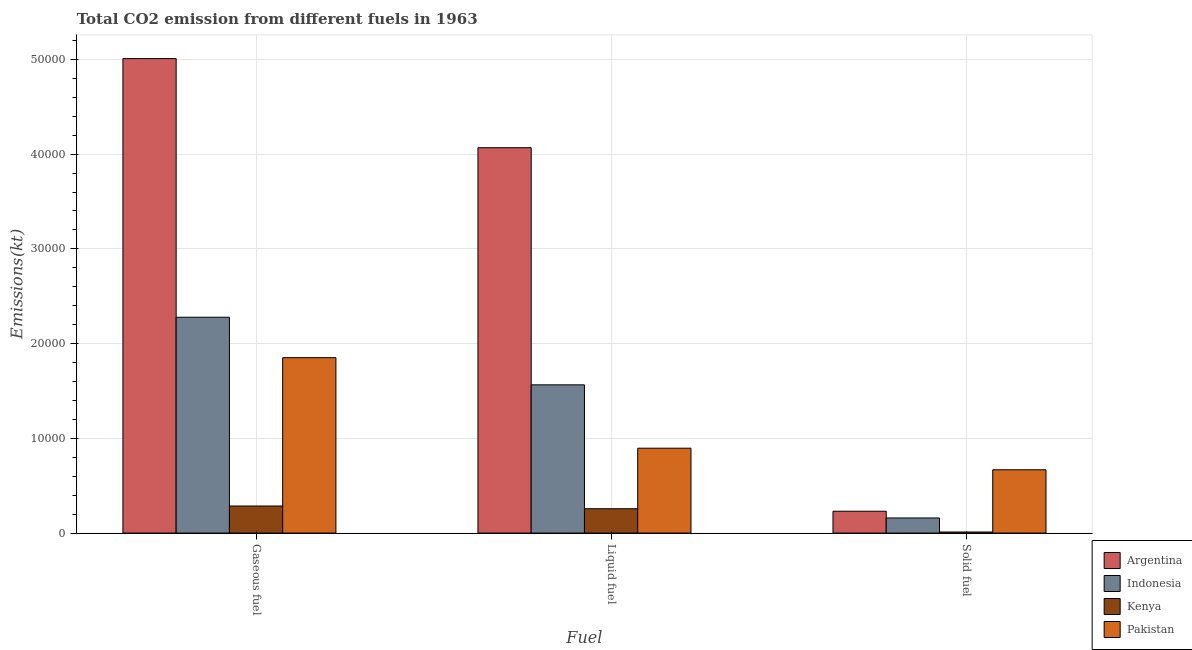How many groups of bars are there?
Your answer should be very brief. 3. Are the number of bars on each tick of the X-axis equal?
Offer a terse response. Yes. What is the label of the 1st group of bars from the left?
Provide a succinct answer. Gaseous fuel. What is the amount of co2 emissions from liquid fuel in Pakistan?
Your answer should be very brief. 8958.48. Across all countries, what is the maximum amount of co2 emissions from liquid fuel?
Provide a short and direct response. 4.07e+04. Across all countries, what is the minimum amount of co2 emissions from gaseous fuel?
Offer a terse response. 2856.59. In which country was the amount of co2 emissions from gaseous fuel minimum?
Your response must be concise. Kenya. What is the total amount of co2 emissions from liquid fuel in the graph?
Offer a very short reply. 6.79e+04. What is the difference between the amount of co2 emissions from liquid fuel in Indonesia and that in Kenya?
Give a very brief answer. 1.31e+04. What is the difference between the amount of co2 emissions from gaseous fuel in Pakistan and the amount of co2 emissions from liquid fuel in Kenya?
Your answer should be compact. 1.59e+04. What is the average amount of co2 emissions from solid fuel per country?
Your answer should be compact. 2674.16. What is the difference between the amount of co2 emissions from gaseous fuel and amount of co2 emissions from solid fuel in Argentina?
Your response must be concise. 4.78e+04. In how many countries, is the amount of co2 emissions from solid fuel greater than 50000 kt?
Give a very brief answer. 0. What is the ratio of the amount of co2 emissions from solid fuel in Pakistan to that in Kenya?
Offer a very short reply. 58.77. Is the amount of co2 emissions from solid fuel in Argentina less than that in Indonesia?
Your response must be concise. No. Is the difference between the amount of co2 emissions from solid fuel in Argentina and Kenya greater than the difference between the amount of co2 emissions from liquid fuel in Argentina and Kenya?
Ensure brevity in your answer.  No. What is the difference between the highest and the second highest amount of co2 emissions from liquid fuel?
Offer a very short reply. 2.50e+04. What is the difference between the highest and the lowest amount of co2 emissions from gaseous fuel?
Your response must be concise. 4.72e+04. In how many countries, is the amount of co2 emissions from liquid fuel greater than the average amount of co2 emissions from liquid fuel taken over all countries?
Keep it short and to the point. 1. Is the sum of the amount of co2 emissions from liquid fuel in Pakistan and Kenya greater than the maximum amount of co2 emissions from solid fuel across all countries?
Offer a very short reply. Yes. What does the 3rd bar from the right in Liquid fuel represents?
Your answer should be very brief. Indonesia. Is it the case that in every country, the sum of the amount of co2 emissions from gaseous fuel and amount of co2 emissions from liquid fuel is greater than the amount of co2 emissions from solid fuel?
Ensure brevity in your answer.  Yes. Are the values on the major ticks of Y-axis written in scientific E-notation?
Ensure brevity in your answer.  No. Where does the legend appear in the graph?
Keep it short and to the point. Bottom right. How are the legend labels stacked?
Give a very brief answer. Vertical. What is the title of the graph?
Offer a very short reply. Total CO2 emission from different fuels in 1963. Does "Suriname" appear as one of the legend labels in the graph?
Ensure brevity in your answer.  No. What is the label or title of the X-axis?
Your response must be concise. Fuel. What is the label or title of the Y-axis?
Offer a terse response. Emissions(kt). What is the Emissions(kt) of Argentina in Gaseous fuel?
Your answer should be very brief. 5.01e+04. What is the Emissions(kt) in Indonesia in Gaseous fuel?
Give a very brief answer. 2.28e+04. What is the Emissions(kt) of Kenya in Gaseous fuel?
Provide a succinct answer. 2856.59. What is the Emissions(kt) in Pakistan in Gaseous fuel?
Offer a very short reply. 1.85e+04. What is the Emissions(kt) of Argentina in Liquid fuel?
Provide a succinct answer. 4.07e+04. What is the Emissions(kt) of Indonesia in Liquid fuel?
Your answer should be compact. 1.56e+04. What is the Emissions(kt) in Kenya in Liquid fuel?
Make the answer very short. 2570.57. What is the Emissions(kt) in Pakistan in Liquid fuel?
Your answer should be compact. 8958.48. What is the Emissions(kt) in Argentina in Solid fuel?
Offer a terse response. 2306.54. What is the Emissions(kt) in Indonesia in Solid fuel?
Your answer should be compact. 1595.14. What is the Emissions(kt) in Kenya in Solid fuel?
Your response must be concise. 113.68. What is the Emissions(kt) of Pakistan in Solid fuel?
Offer a very short reply. 6681.27. Across all Fuel, what is the maximum Emissions(kt) in Argentina?
Offer a very short reply. 5.01e+04. Across all Fuel, what is the maximum Emissions(kt) of Indonesia?
Offer a very short reply. 2.28e+04. Across all Fuel, what is the maximum Emissions(kt) of Kenya?
Give a very brief answer. 2856.59. Across all Fuel, what is the maximum Emissions(kt) of Pakistan?
Provide a short and direct response. 1.85e+04. Across all Fuel, what is the minimum Emissions(kt) in Argentina?
Your response must be concise. 2306.54. Across all Fuel, what is the minimum Emissions(kt) of Indonesia?
Offer a terse response. 1595.14. Across all Fuel, what is the minimum Emissions(kt) in Kenya?
Offer a very short reply. 113.68. Across all Fuel, what is the minimum Emissions(kt) of Pakistan?
Your response must be concise. 6681.27. What is the total Emissions(kt) of Argentina in the graph?
Keep it short and to the point. 9.31e+04. What is the total Emissions(kt) of Indonesia in the graph?
Keep it short and to the point. 4.00e+04. What is the total Emissions(kt) of Kenya in the graph?
Offer a terse response. 5540.84. What is the total Emissions(kt) in Pakistan in the graph?
Your response must be concise. 3.42e+04. What is the difference between the Emissions(kt) of Argentina in Gaseous fuel and that in Liquid fuel?
Give a very brief answer. 9405.85. What is the difference between the Emissions(kt) in Indonesia in Gaseous fuel and that in Liquid fuel?
Your answer should be very brief. 7135.98. What is the difference between the Emissions(kt) in Kenya in Gaseous fuel and that in Liquid fuel?
Make the answer very short. 286.03. What is the difference between the Emissions(kt) in Pakistan in Gaseous fuel and that in Liquid fuel?
Offer a terse response. 9556.2. What is the difference between the Emissions(kt) of Argentina in Gaseous fuel and that in Solid fuel?
Provide a succinct answer. 4.78e+04. What is the difference between the Emissions(kt) in Indonesia in Gaseous fuel and that in Solid fuel?
Provide a succinct answer. 2.12e+04. What is the difference between the Emissions(kt) of Kenya in Gaseous fuel and that in Solid fuel?
Offer a terse response. 2742.92. What is the difference between the Emissions(kt) in Pakistan in Gaseous fuel and that in Solid fuel?
Keep it short and to the point. 1.18e+04. What is the difference between the Emissions(kt) in Argentina in Liquid fuel and that in Solid fuel?
Keep it short and to the point. 3.84e+04. What is the difference between the Emissions(kt) in Indonesia in Liquid fuel and that in Solid fuel?
Give a very brief answer. 1.41e+04. What is the difference between the Emissions(kt) in Kenya in Liquid fuel and that in Solid fuel?
Your answer should be very brief. 2456.89. What is the difference between the Emissions(kt) of Pakistan in Liquid fuel and that in Solid fuel?
Ensure brevity in your answer.  2277.21. What is the difference between the Emissions(kt) of Argentina in Gaseous fuel and the Emissions(kt) of Indonesia in Liquid fuel?
Your answer should be compact. 3.44e+04. What is the difference between the Emissions(kt) in Argentina in Gaseous fuel and the Emissions(kt) in Kenya in Liquid fuel?
Keep it short and to the point. 4.75e+04. What is the difference between the Emissions(kt) in Argentina in Gaseous fuel and the Emissions(kt) in Pakistan in Liquid fuel?
Provide a succinct answer. 4.11e+04. What is the difference between the Emissions(kt) in Indonesia in Gaseous fuel and the Emissions(kt) in Kenya in Liquid fuel?
Ensure brevity in your answer.  2.02e+04. What is the difference between the Emissions(kt) in Indonesia in Gaseous fuel and the Emissions(kt) in Pakistan in Liquid fuel?
Make the answer very short. 1.38e+04. What is the difference between the Emissions(kt) of Kenya in Gaseous fuel and the Emissions(kt) of Pakistan in Liquid fuel?
Provide a succinct answer. -6101.89. What is the difference between the Emissions(kt) in Argentina in Gaseous fuel and the Emissions(kt) in Indonesia in Solid fuel?
Provide a succinct answer. 4.85e+04. What is the difference between the Emissions(kt) of Argentina in Gaseous fuel and the Emissions(kt) of Kenya in Solid fuel?
Offer a very short reply. 5.00e+04. What is the difference between the Emissions(kt) of Argentina in Gaseous fuel and the Emissions(kt) of Pakistan in Solid fuel?
Provide a succinct answer. 4.34e+04. What is the difference between the Emissions(kt) of Indonesia in Gaseous fuel and the Emissions(kt) of Kenya in Solid fuel?
Provide a short and direct response. 2.27e+04. What is the difference between the Emissions(kt) in Indonesia in Gaseous fuel and the Emissions(kt) in Pakistan in Solid fuel?
Provide a succinct answer. 1.61e+04. What is the difference between the Emissions(kt) in Kenya in Gaseous fuel and the Emissions(kt) in Pakistan in Solid fuel?
Your response must be concise. -3824.68. What is the difference between the Emissions(kt) of Argentina in Liquid fuel and the Emissions(kt) of Indonesia in Solid fuel?
Your answer should be very brief. 3.91e+04. What is the difference between the Emissions(kt) of Argentina in Liquid fuel and the Emissions(kt) of Kenya in Solid fuel?
Offer a very short reply. 4.06e+04. What is the difference between the Emissions(kt) in Argentina in Liquid fuel and the Emissions(kt) in Pakistan in Solid fuel?
Give a very brief answer. 3.40e+04. What is the difference between the Emissions(kt) in Indonesia in Liquid fuel and the Emissions(kt) in Kenya in Solid fuel?
Your response must be concise. 1.55e+04. What is the difference between the Emissions(kt) in Indonesia in Liquid fuel and the Emissions(kt) in Pakistan in Solid fuel?
Your response must be concise. 8965.82. What is the difference between the Emissions(kt) in Kenya in Liquid fuel and the Emissions(kt) in Pakistan in Solid fuel?
Offer a very short reply. -4110.71. What is the average Emissions(kt) in Argentina per Fuel?
Your answer should be compact. 3.10e+04. What is the average Emissions(kt) in Indonesia per Fuel?
Your answer should be compact. 1.33e+04. What is the average Emissions(kt) of Kenya per Fuel?
Offer a terse response. 1846.95. What is the average Emissions(kt) of Pakistan per Fuel?
Ensure brevity in your answer.  1.14e+04. What is the difference between the Emissions(kt) in Argentina and Emissions(kt) in Indonesia in Gaseous fuel?
Offer a very short reply. 2.73e+04. What is the difference between the Emissions(kt) of Argentina and Emissions(kt) of Kenya in Gaseous fuel?
Your response must be concise. 4.72e+04. What is the difference between the Emissions(kt) of Argentina and Emissions(kt) of Pakistan in Gaseous fuel?
Offer a terse response. 3.16e+04. What is the difference between the Emissions(kt) in Indonesia and Emissions(kt) in Kenya in Gaseous fuel?
Offer a very short reply. 1.99e+04. What is the difference between the Emissions(kt) of Indonesia and Emissions(kt) of Pakistan in Gaseous fuel?
Ensure brevity in your answer.  4268.39. What is the difference between the Emissions(kt) in Kenya and Emissions(kt) in Pakistan in Gaseous fuel?
Provide a short and direct response. -1.57e+04. What is the difference between the Emissions(kt) of Argentina and Emissions(kt) of Indonesia in Liquid fuel?
Offer a terse response. 2.50e+04. What is the difference between the Emissions(kt) in Argentina and Emissions(kt) in Kenya in Liquid fuel?
Your response must be concise. 3.81e+04. What is the difference between the Emissions(kt) in Argentina and Emissions(kt) in Pakistan in Liquid fuel?
Your response must be concise. 3.17e+04. What is the difference between the Emissions(kt) in Indonesia and Emissions(kt) in Kenya in Liquid fuel?
Your answer should be compact. 1.31e+04. What is the difference between the Emissions(kt) of Indonesia and Emissions(kt) of Pakistan in Liquid fuel?
Ensure brevity in your answer.  6688.61. What is the difference between the Emissions(kt) of Kenya and Emissions(kt) of Pakistan in Liquid fuel?
Your answer should be compact. -6387.91. What is the difference between the Emissions(kt) of Argentina and Emissions(kt) of Indonesia in Solid fuel?
Provide a succinct answer. 711.4. What is the difference between the Emissions(kt) of Argentina and Emissions(kt) of Kenya in Solid fuel?
Keep it short and to the point. 2192.87. What is the difference between the Emissions(kt) in Argentina and Emissions(kt) in Pakistan in Solid fuel?
Your response must be concise. -4374.73. What is the difference between the Emissions(kt) of Indonesia and Emissions(kt) of Kenya in Solid fuel?
Give a very brief answer. 1481.47. What is the difference between the Emissions(kt) of Indonesia and Emissions(kt) of Pakistan in Solid fuel?
Your answer should be very brief. -5086.13. What is the difference between the Emissions(kt) of Kenya and Emissions(kt) of Pakistan in Solid fuel?
Provide a succinct answer. -6567.6. What is the ratio of the Emissions(kt) in Argentina in Gaseous fuel to that in Liquid fuel?
Offer a terse response. 1.23. What is the ratio of the Emissions(kt) of Indonesia in Gaseous fuel to that in Liquid fuel?
Your answer should be very brief. 1.46. What is the ratio of the Emissions(kt) in Kenya in Gaseous fuel to that in Liquid fuel?
Keep it short and to the point. 1.11. What is the ratio of the Emissions(kt) of Pakistan in Gaseous fuel to that in Liquid fuel?
Give a very brief answer. 2.07. What is the ratio of the Emissions(kt) in Argentina in Gaseous fuel to that in Solid fuel?
Provide a succinct answer. 21.71. What is the ratio of the Emissions(kt) in Indonesia in Gaseous fuel to that in Solid fuel?
Offer a terse response. 14.28. What is the ratio of the Emissions(kt) in Kenya in Gaseous fuel to that in Solid fuel?
Your answer should be very brief. 25.13. What is the ratio of the Emissions(kt) of Pakistan in Gaseous fuel to that in Solid fuel?
Offer a terse response. 2.77. What is the ratio of the Emissions(kt) of Argentina in Liquid fuel to that in Solid fuel?
Make the answer very short. 17.64. What is the ratio of the Emissions(kt) of Indonesia in Liquid fuel to that in Solid fuel?
Offer a terse response. 9.81. What is the ratio of the Emissions(kt) of Kenya in Liquid fuel to that in Solid fuel?
Offer a very short reply. 22.61. What is the ratio of the Emissions(kt) of Pakistan in Liquid fuel to that in Solid fuel?
Offer a very short reply. 1.34. What is the difference between the highest and the second highest Emissions(kt) in Argentina?
Your response must be concise. 9405.85. What is the difference between the highest and the second highest Emissions(kt) of Indonesia?
Provide a short and direct response. 7135.98. What is the difference between the highest and the second highest Emissions(kt) of Kenya?
Keep it short and to the point. 286.03. What is the difference between the highest and the second highest Emissions(kt) in Pakistan?
Your answer should be compact. 9556.2. What is the difference between the highest and the lowest Emissions(kt) in Argentina?
Keep it short and to the point. 4.78e+04. What is the difference between the highest and the lowest Emissions(kt) of Indonesia?
Make the answer very short. 2.12e+04. What is the difference between the highest and the lowest Emissions(kt) of Kenya?
Keep it short and to the point. 2742.92. What is the difference between the highest and the lowest Emissions(kt) of Pakistan?
Keep it short and to the point. 1.18e+04. 